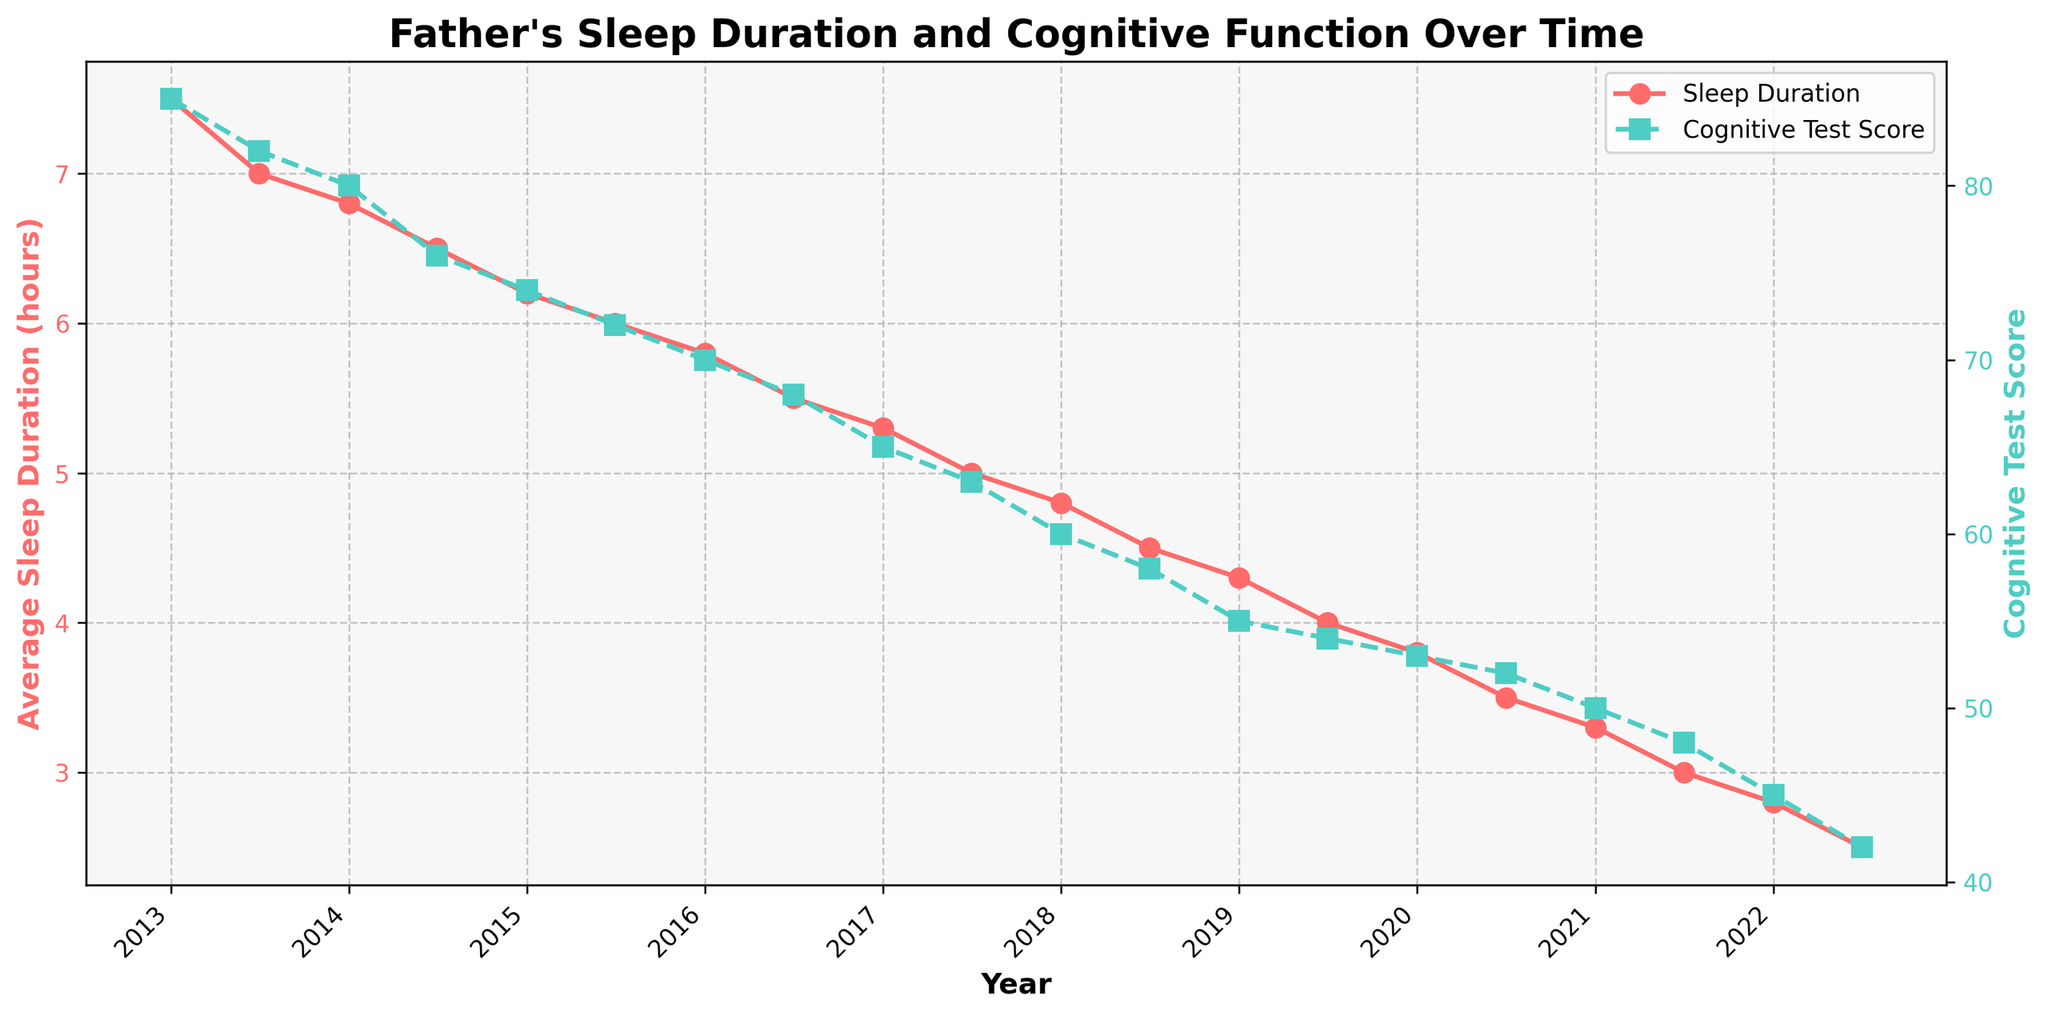What is the title of the plot? The title is displayed right at the top center of the plot. It provides an overview of what the plot represents.
Answer: Father's Sleep Duration and Cognitive Function Over Time What is the average sleep duration in January 2016? To find this, locate January 2016 on the x-axis and refer to the corresponding value on the sleep duration line (red color).
Answer: 5.8 hours How did the cognitive test scores change from January 2013 to July 2022? Identify the cognitive test score in January 2013 and the score in July 2022 from the line (green color) and subtract the latter from the former.
Answer: Decreased by 43 points During which year did the average sleep duration drop below 5 hours for the first time? Look at the trend in the sleep duration line (red color) and identify the first date that the value goes below 5 hours.
Answer: 2017 Did average sleep duration display a generally increasing or decreasing trend over the past decade? Observe the overall direction of the sleep duration line (red color) from the start to the end of the plot.
Answer: Decreasing Which month and year recorded the lowest cognitive test score? To find this, follow the cognitive test score line (green color) and identify the lowest point. Check the corresponding date.
Answer: July 2022 How many data points are shown for cognitive test scores? Count the number of markers (squares) on the cognitive test score line (green color).
Answer: 20 What is the visual color scheme used for representing average sleep duration and cognitive test scores? Look at the colors of the lines and markers representing the different variables in the plot.
Answer: Red for sleep duration, Green for cognitive test scores Which data point shows the largest drop in sleep duration? Compare the differences in adjacent data points on the sleep duration line (red color) and identify the largest drop.
Answer: From July 2016 to January 2017 Is there an apparent correlation between average sleep duration and cognitive test scores? Compare the trends in both lines (red for sleep duration and green for cognitive test scores) to see if they move together or inversely.
Answer: Yes, both decrease over time 